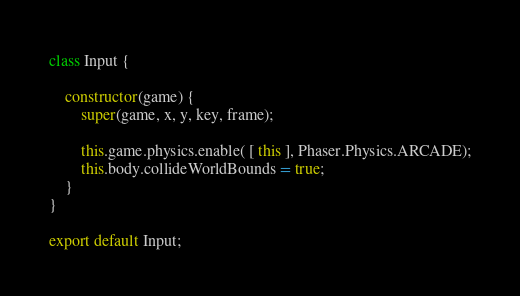<code> <loc_0><loc_0><loc_500><loc_500><_JavaScript_>class Input {

	constructor(game) {
		super(game, x, y, key, frame);

    	this.game.physics.enable( [ this ], Phaser.Physics.ARCADE);
    	this.body.collideWorldBounds = true;
	}
}

export default Input;</code> 